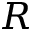<formula> <loc_0><loc_0><loc_500><loc_500>R</formula> 